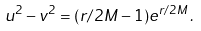Convert formula to latex. <formula><loc_0><loc_0><loc_500><loc_500>u ^ { 2 } - v ^ { 2 } = ( r / 2 M - 1 ) e ^ { r / 2 M } \, .</formula> 